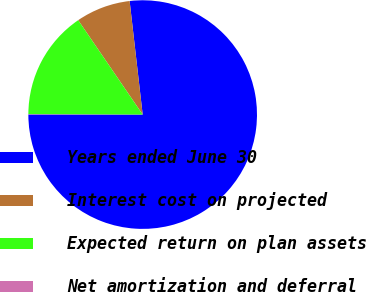<chart> <loc_0><loc_0><loc_500><loc_500><pie_chart><fcel>Years ended June 30<fcel>Interest cost on projected<fcel>Expected return on plan assets<fcel>Net amortization and deferral<nl><fcel>76.83%<fcel>7.72%<fcel>15.4%<fcel>0.05%<nl></chart> 